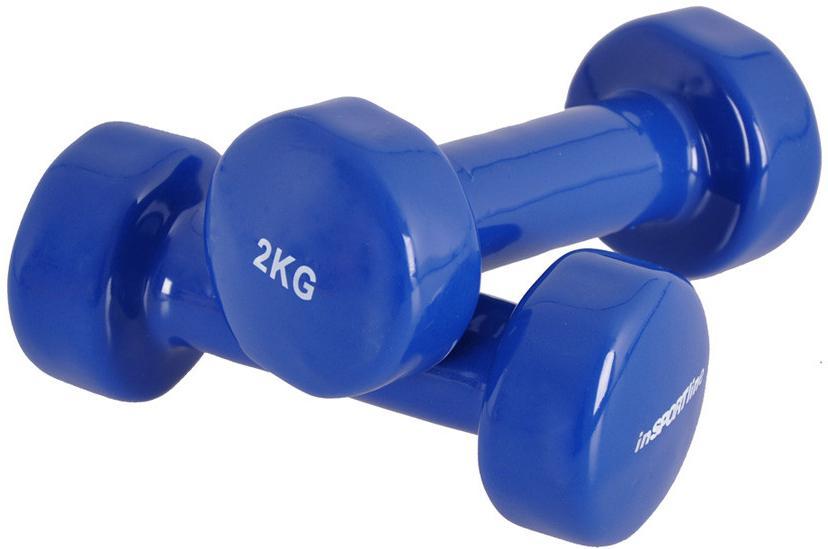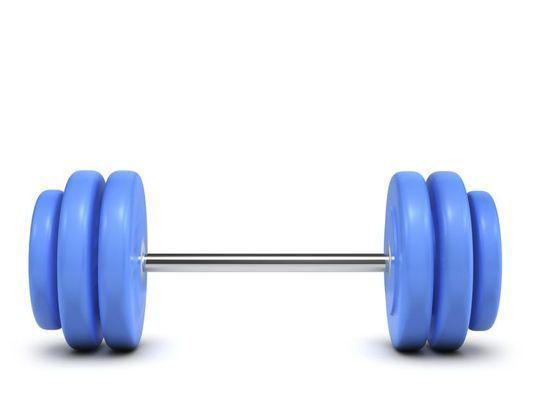The first image is the image on the left, the second image is the image on the right. Examine the images to the left and right. Is the description "A row of six dumbbells appears in one image, arranged in a sequence from least to most weight." accurate? Answer yes or no. No. 